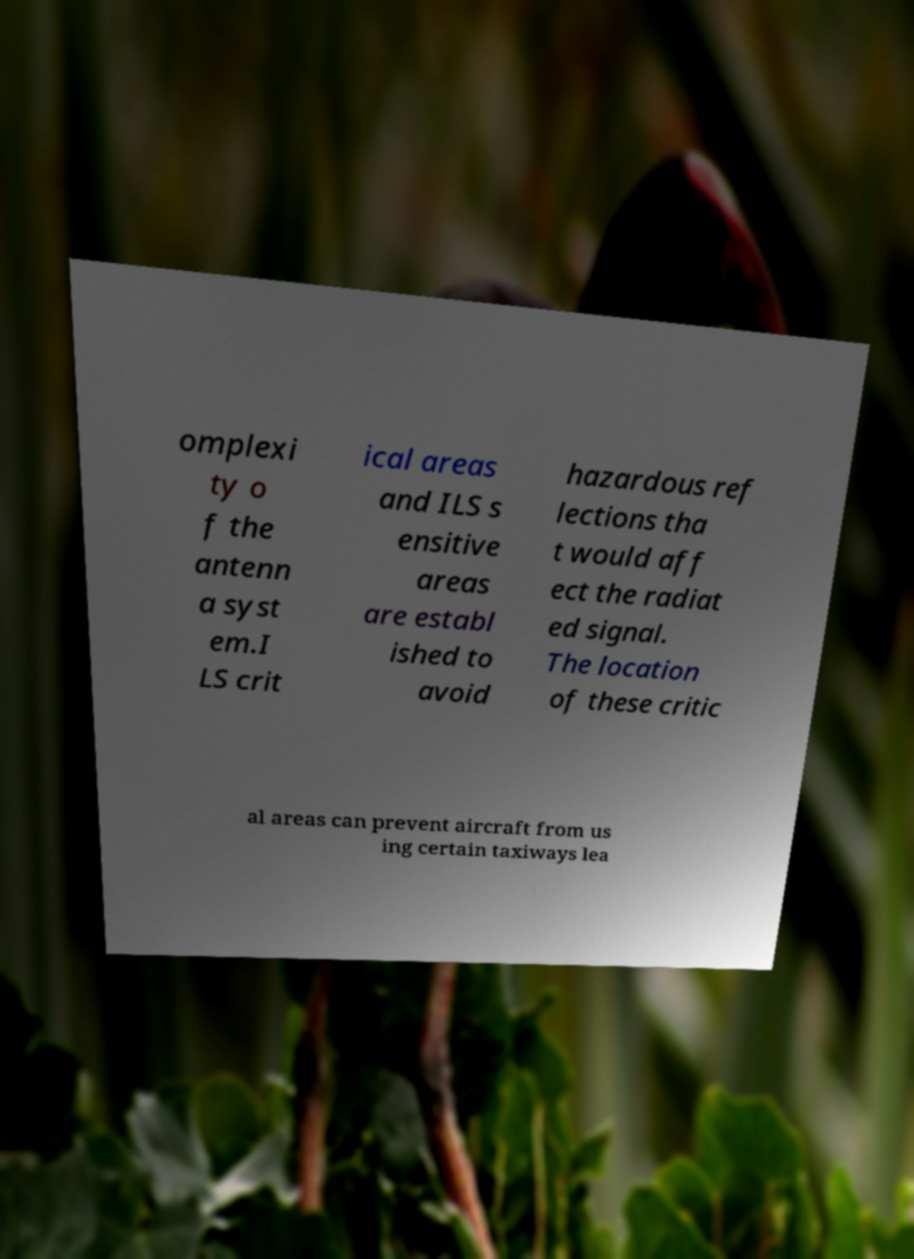Can you read and provide the text displayed in the image?This photo seems to have some interesting text. Can you extract and type it out for me? omplexi ty o f the antenn a syst em.I LS crit ical areas and ILS s ensitive areas are establ ished to avoid hazardous ref lections tha t would aff ect the radiat ed signal. The location of these critic al areas can prevent aircraft from us ing certain taxiways lea 